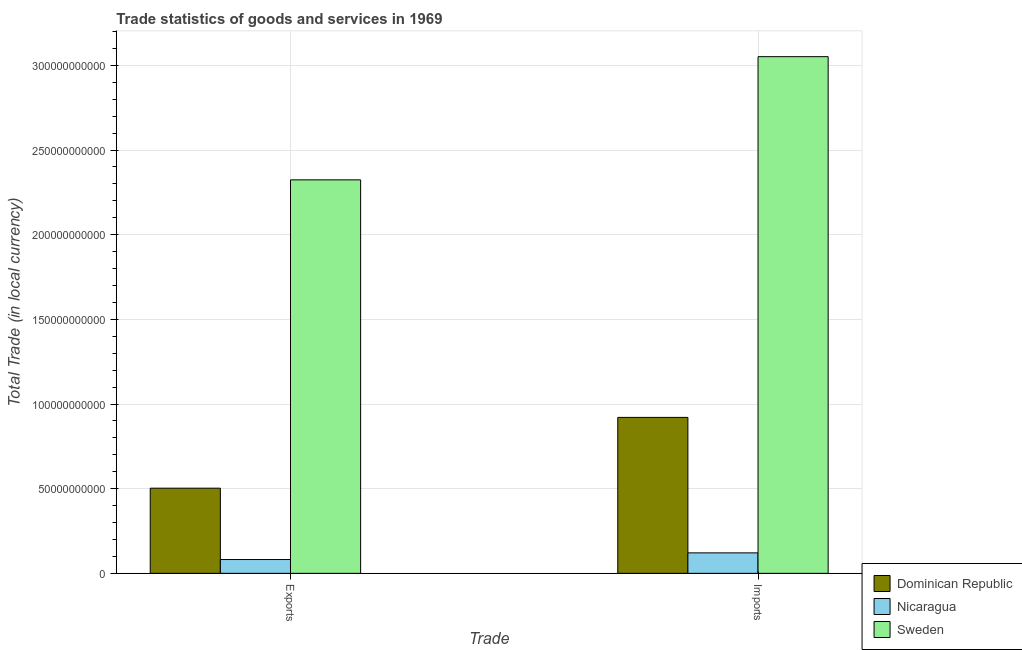How many different coloured bars are there?
Provide a short and direct response. 3. How many groups of bars are there?
Provide a succinct answer. 2. Are the number of bars per tick equal to the number of legend labels?
Offer a very short reply. Yes. Are the number of bars on each tick of the X-axis equal?
Provide a succinct answer. Yes. How many bars are there on the 1st tick from the left?
Make the answer very short. 3. How many bars are there on the 2nd tick from the right?
Provide a short and direct response. 3. What is the label of the 1st group of bars from the left?
Give a very brief answer. Exports. What is the export of goods and services in Dominican Republic?
Your answer should be very brief. 5.03e+1. Across all countries, what is the maximum export of goods and services?
Make the answer very short. 2.32e+11. Across all countries, what is the minimum export of goods and services?
Your answer should be very brief. 8.14e+09. In which country was the export of goods and services minimum?
Provide a short and direct response. Nicaragua. What is the total imports of goods and services in the graph?
Your answer should be compact. 4.09e+11. What is the difference between the imports of goods and services in Nicaragua and that in Dominican Republic?
Your response must be concise. -8.00e+1. What is the difference between the imports of goods and services in Dominican Republic and the export of goods and services in Sweden?
Provide a succinct answer. -1.40e+11. What is the average export of goods and services per country?
Offer a terse response. 9.69e+1. What is the difference between the export of goods and services and imports of goods and services in Nicaragua?
Provide a short and direct response. -3.94e+09. In how many countries, is the imports of goods and services greater than 180000000000 LCU?
Offer a terse response. 1. What is the ratio of the imports of goods and services in Dominican Republic to that in Nicaragua?
Keep it short and to the point. 7.62. Is the imports of goods and services in Sweden less than that in Dominican Republic?
Provide a succinct answer. No. What does the 2nd bar from the left in Imports represents?
Your answer should be compact. Nicaragua. What does the 2nd bar from the right in Exports represents?
Offer a very short reply. Nicaragua. How many bars are there?
Your answer should be very brief. 6. How many countries are there in the graph?
Give a very brief answer. 3. What is the difference between two consecutive major ticks on the Y-axis?
Your answer should be very brief. 5.00e+1. Are the values on the major ticks of Y-axis written in scientific E-notation?
Make the answer very short. No. Does the graph contain any zero values?
Offer a terse response. No. Does the graph contain grids?
Offer a terse response. Yes. Where does the legend appear in the graph?
Provide a succinct answer. Bottom right. How are the legend labels stacked?
Offer a terse response. Vertical. What is the title of the graph?
Offer a terse response. Trade statistics of goods and services in 1969. What is the label or title of the X-axis?
Your response must be concise. Trade. What is the label or title of the Y-axis?
Offer a very short reply. Total Trade (in local currency). What is the Total Trade (in local currency) of Dominican Republic in Exports?
Your answer should be compact. 5.03e+1. What is the Total Trade (in local currency) in Nicaragua in Exports?
Your answer should be very brief. 8.14e+09. What is the Total Trade (in local currency) in Sweden in Exports?
Give a very brief answer. 2.32e+11. What is the Total Trade (in local currency) in Dominican Republic in Imports?
Offer a very short reply. 9.21e+1. What is the Total Trade (in local currency) of Nicaragua in Imports?
Make the answer very short. 1.21e+1. What is the Total Trade (in local currency) of Sweden in Imports?
Your answer should be compact. 3.05e+11. Across all Trade, what is the maximum Total Trade (in local currency) of Dominican Republic?
Keep it short and to the point. 9.21e+1. Across all Trade, what is the maximum Total Trade (in local currency) in Nicaragua?
Offer a very short reply. 1.21e+1. Across all Trade, what is the maximum Total Trade (in local currency) in Sweden?
Your answer should be very brief. 3.05e+11. Across all Trade, what is the minimum Total Trade (in local currency) in Dominican Republic?
Offer a terse response. 5.03e+1. Across all Trade, what is the minimum Total Trade (in local currency) of Nicaragua?
Make the answer very short. 8.14e+09. Across all Trade, what is the minimum Total Trade (in local currency) in Sweden?
Offer a very short reply. 2.32e+11. What is the total Total Trade (in local currency) in Dominican Republic in the graph?
Your answer should be very brief. 1.42e+11. What is the total Total Trade (in local currency) of Nicaragua in the graph?
Give a very brief answer. 2.02e+1. What is the total Total Trade (in local currency) of Sweden in the graph?
Provide a short and direct response. 5.38e+11. What is the difference between the Total Trade (in local currency) in Dominican Republic in Exports and that in Imports?
Give a very brief answer. -4.18e+1. What is the difference between the Total Trade (in local currency) in Nicaragua in Exports and that in Imports?
Keep it short and to the point. -3.94e+09. What is the difference between the Total Trade (in local currency) of Sweden in Exports and that in Imports?
Offer a very short reply. -7.28e+1. What is the difference between the Total Trade (in local currency) in Dominican Republic in Exports and the Total Trade (in local currency) in Nicaragua in Imports?
Keep it short and to the point. 3.82e+1. What is the difference between the Total Trade (in local currency) in Dominican Republic in Exports and the Total Trade (in local currency) in Sweden in Imports?
Offer a terse response. -2.55e+11. What is the difference between the Total Trade (in local currency) in Nicaragua in Exports and the Total Trade (in local currency) in Sweden in Imports?
Provide a succinct answer. -2.97e+11. What is the average Total Trade (in local currency) of Dominican Republic per Trade?
Make the answer very short. 7.12e+1. What is the average Total Trade (in local currency) in Nicaragua per Trade?
Provide a short and direct response. 1.01e+1. What is the average Total Trade (in local currency) of Sweden per Trade?
Ensure brevity in your answer.  2.69e+11. What is the difference between the Total Trade (in local currency) of Dominican Republic and Total Trade (in local currency) of Nicaragua in Exports?
Offer a very short reply. 4.21e+1. What is the difference between the Total Trade (in local currency) of Dominican Republic and Total Trade (in local currency) of Sweden in Exports?
Provide a succinct answer. -1.82e+11. What is the difference between the Total Trade (in local currency) of Nicaragua and Total Trade (in local currency) of Sweden in Exports?
Your response must be concise. -2.24e+11. What is the difference between the Total Trade (in local currency) of Dominican Republic and Total Trade (in local currency) of Nicaragua in Imports?
Your response must be concise. 8.00e+1. What is the difference between the Total Trade (in local currency) in Dominican Republic and Total Trade (in local currency) in Sweden in Imports?
Make the answer very short. -2.13e+11. What is the difference between the Total Trade (in local currency) of Nicaragua and Total Trade (in local currency) of Sweden in Imports?
Make the answer very short. -2.93e+11. What is the ratio of the Total Trade (in local currency) of Dominican Republic in Exports to that in Imports?
Your response must be concise. 0.55. What is the ratio of the Total Trade (in local currency) in Nicaragua in Exports to that in Imports?
Your answer should be very brief. 0.67. What is the ratio of the Total Trade (in local currency) of Sweden in Exports to that in Imports?
Give a very brief answer. 0.76. What is the difference between the highest and the second highest Total Trade (in local currency) of Dominican Republic?
Offer a very short reply. 4.18e+1. What is the difference between the highest and the second highest Total Trade (in local currency) of Nicaragua?
Your answer should be very brief. 3.94e+09. What is the difference between the highest and the second highest Total Trade (in local currency) of Sweden?
Your response must be concise. 7.28e+1. What is the difference between the highest and the lowest Total Trade (in local currency) of Dominican Republic?
Make the answer very short. 4.18e+1. What is the difference between the highest and the lowest Total Trade (in local currency) of Nicaragua?
Offer a terse response. 3.94e+09. What is the difference between the highest and the lowest Total Trade (in local currency) in Sweden?
Offer a terse response. 7.28e+1. 